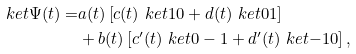Convert formula to latex. <formula><loc_0><loc_0><loc_500><loc_500>\ k e t { \Psi ( t ) } = & a ( t ) \left [ c ( t ) \ k e t { 1 0 } + d ( t ) \ k e t { 0 1 } \right ] \\ & + b ( t ) \left [ c ^ { \prime } ( t ) \ k e t { 0 - 1 } + d ^ { \prime } ( t ) \ k e t { - 1 0 } \right ] ,</formula> 